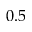Convert formula to latex. <formula><loc_0><loc_0><loc_500><loc_500>0 . 5</formula> 